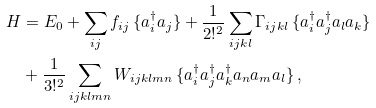Convert formula to latex. <formula><loc_0><loc_0><loc_500><loc_500>H & = E _ { 0 } + \sum _ { i j } f _ { i j } \, \{ a _ { i } ^ { \dagger } a _ { j } \} + \frac { 1 } { 2 ! ^ { 2 } } \sum _ { i j k l } \Gamma _ { i j k l } \, \{ a _ { i } ^ { \dagger } a _ { j } ^ { \dagger } a _ { l } a _ { k } \} \\ & + \frac { 1 } { 3 ! ^ { 2 } } \sum _ { i j k l m n } W _ { i j k l m n } \, \{ a _ { i } ^ { \dagger } a _ { j } ^ { \dagger } a _ { k } ^ { \dagger } a _ { n } a _ { m } a _ { l } \} \, ,</formula> 